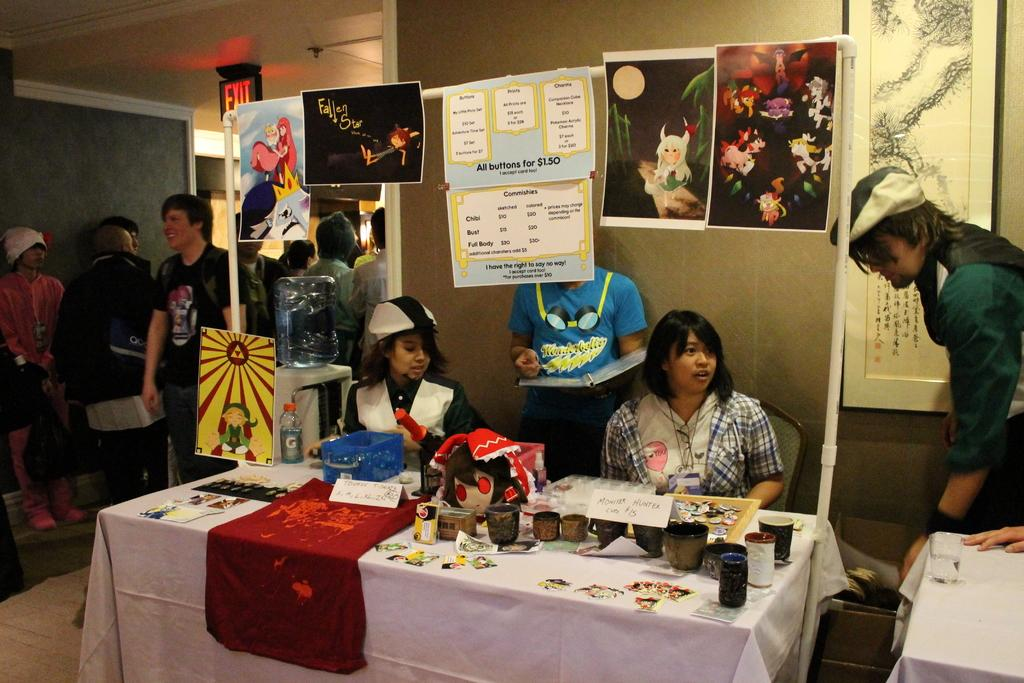What type of decoration is present on the walls in the image? There is wallpaper in the image. What piece of furniture can be seen in the image? There is a table in the image. What items are on the table? There are glasses and a poster on the table. What are the people in the image doing? There are people sitting and standing in the image. What type of minister is depicted in the poster on the table? There is no minister depicted in the poster on the table; the poster is not described in detail. What message of peace is conveyed by the people in the image? There is no indication of a message of peace in the image; it simply shows people sitting and standing. 